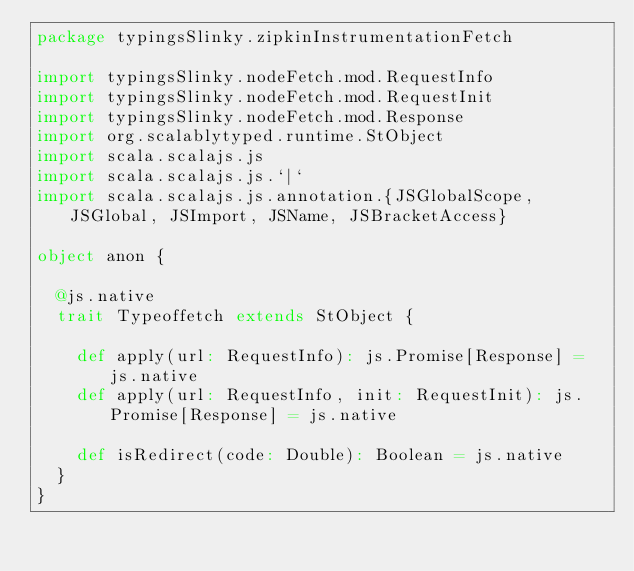<code> <loc_0><loc_0><loc_500><loc_500><_Scala_>package typingsSlinky.zipkinInstrumentationFetch

import typingsSlinky.nodeFetch.mod.RequestInfo
import typingsSlinky.nodeFetch.mod.RequestInit
import typingsSlinky.nodeFetch.mod.Response
import org.scalablytyped.runtime.StObject
import scala.scalajs.js
import scala.scalajs.js.`|`
import scala.scalajs.js.annotation.{JSGlobalScope, JSGlobal, JSImport, JSName, JSBracketAccess}

object anon {
  
  @js.native
  trait Typeoffetch extends StObject {
    
    def apply(url: RequestInfo): js.Promise[Response] = js.native
    def apply(url: RequestInfo, init: RequestInit): js.Promise[Response] = js.native
    
    def isRedirect(code: Double): Boolean = js.native
  }
}
</code> 